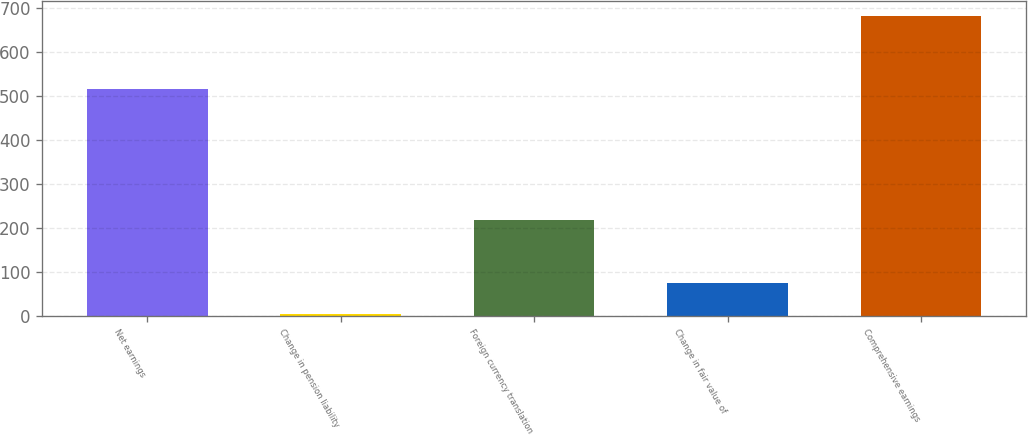Convert chart to OTSL. <chart><loc_0><loc_0><loc_500><loc_500><bar_chart><fcel>Net earnings<fcel>Change in pension liability<fcel>Foreign currency translation<fcel>Change in fair value of<fcel>Comprehensive earnings<nl><fcel>516.9<fcel>4.3<fcel>218.44<fcel>75.68<fcel>681.7<nl></chart> 